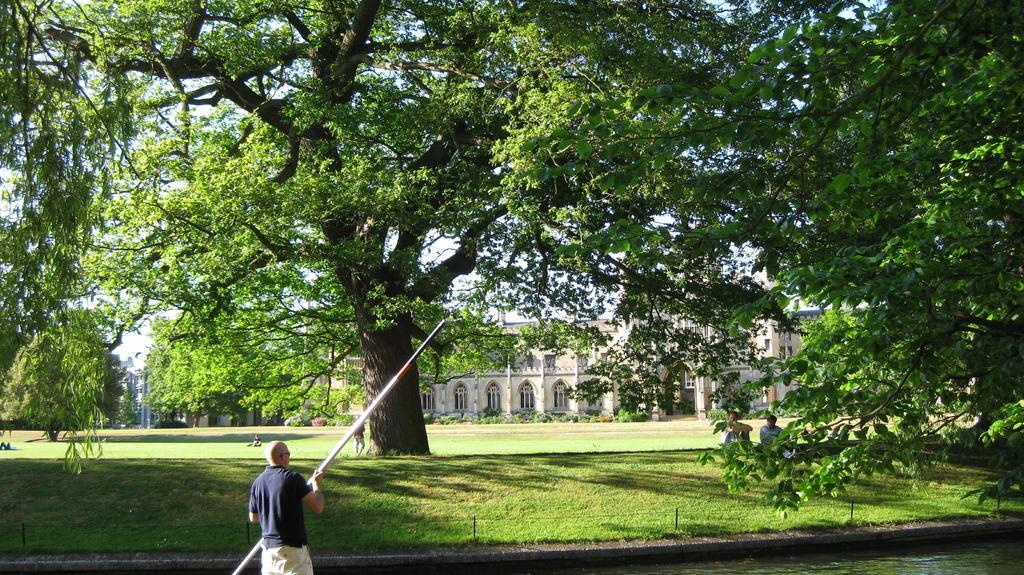Describe this image in one or two sentences. In this image, we can see some trees. There is a building in the middle of the image. There is a person in the middle of the image holding a stick with his hand. There are two person in the bottom right of the image sitting beside the canal. 